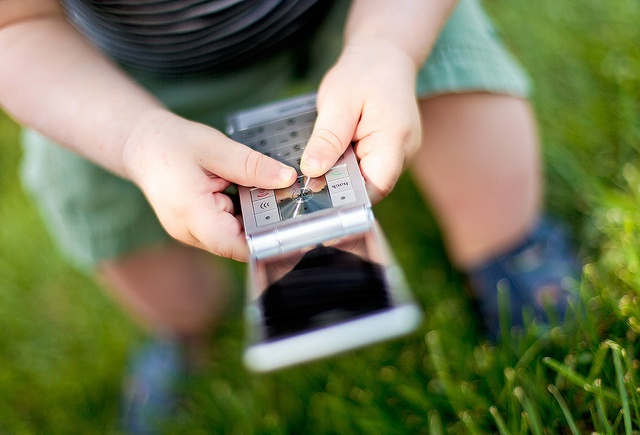Describe the objects in this image and their specific colors. I can see people in salmon, lightgray, black, tan, and gray tones, cell phone in salmon, black, lightgray, darkgray, and gray tones, and people in salmon, lightgray, tan, and darkgray tones in this image. 